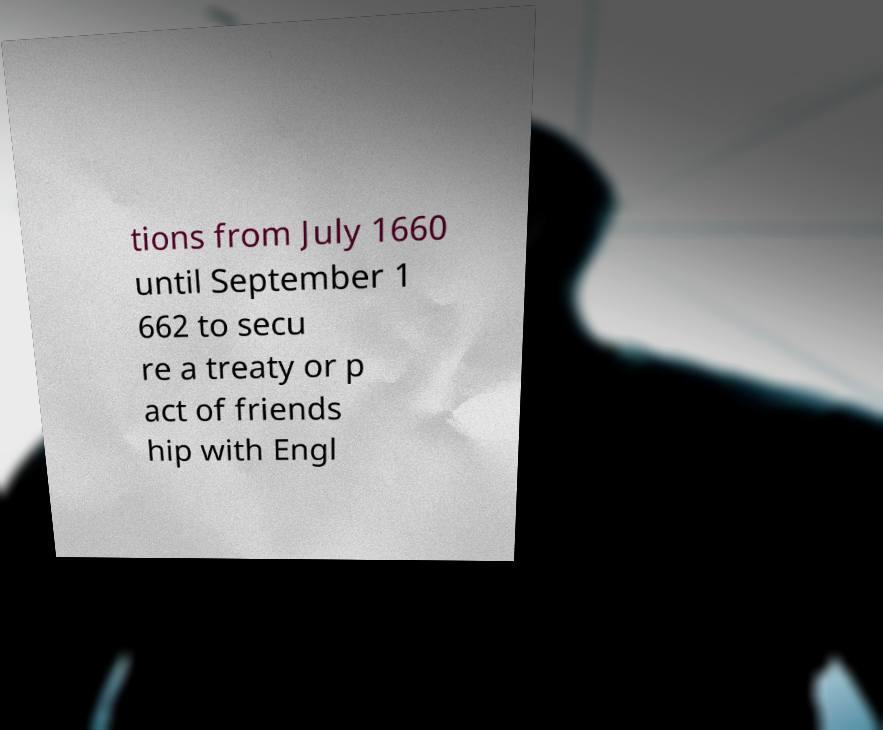There's text embedded in this image that I need extracted. Can you transcribe it verbatim? tions from July 1660 until September 1 662 to secu re a treaty or p act of friends hip with Engl 